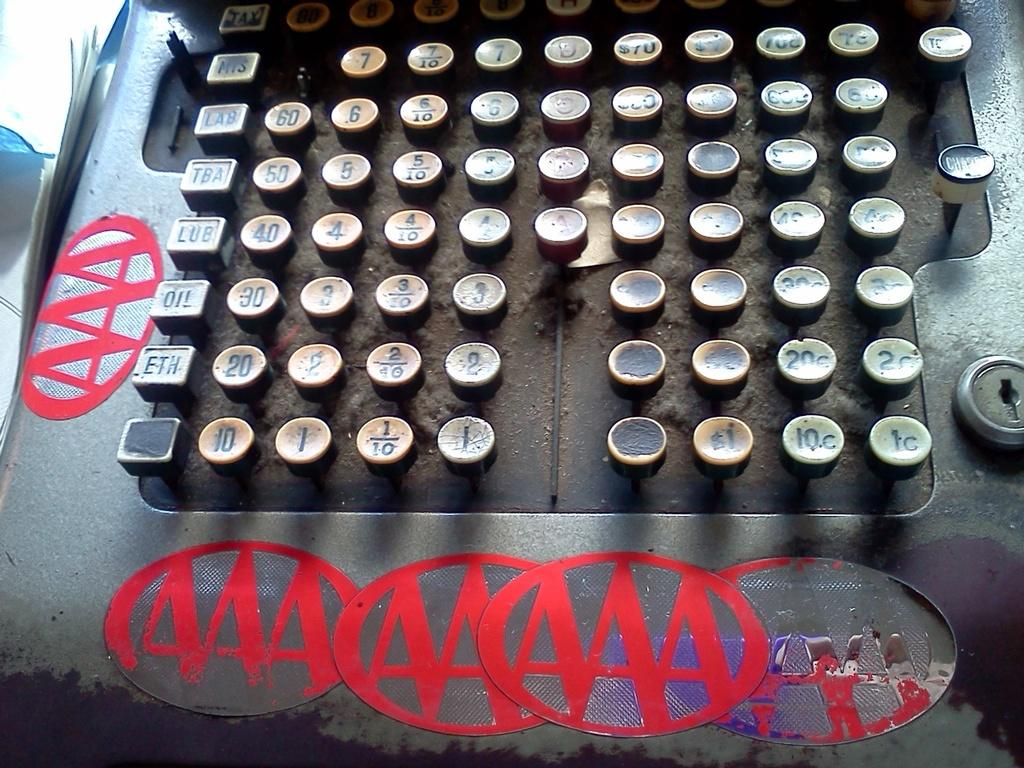What is the main object in the image? There is a machine in the image. What else can be seen in the image besides the machine? There are papers in the image. What features can be observed on the machine? There are keys and stickers on the machine. Can you tell me how many bears are sitting on the machine in the image? There are no bears present in the image; it features a machine with keys and stickers. What type of friend can be seen interacting with the machine in the image? There is no friend present in the image; it only features a machine with keys and stickers. 